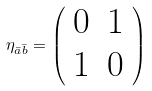Convert formula to latex. <formula><loc_0><loc_0><loc_500><loc_500>\eta _ { \bar { a } \bar { b } } = \left ( \begin{array} { c c } 0 & 1 \\ 1 & 0 \end{array} \right )</formula> 